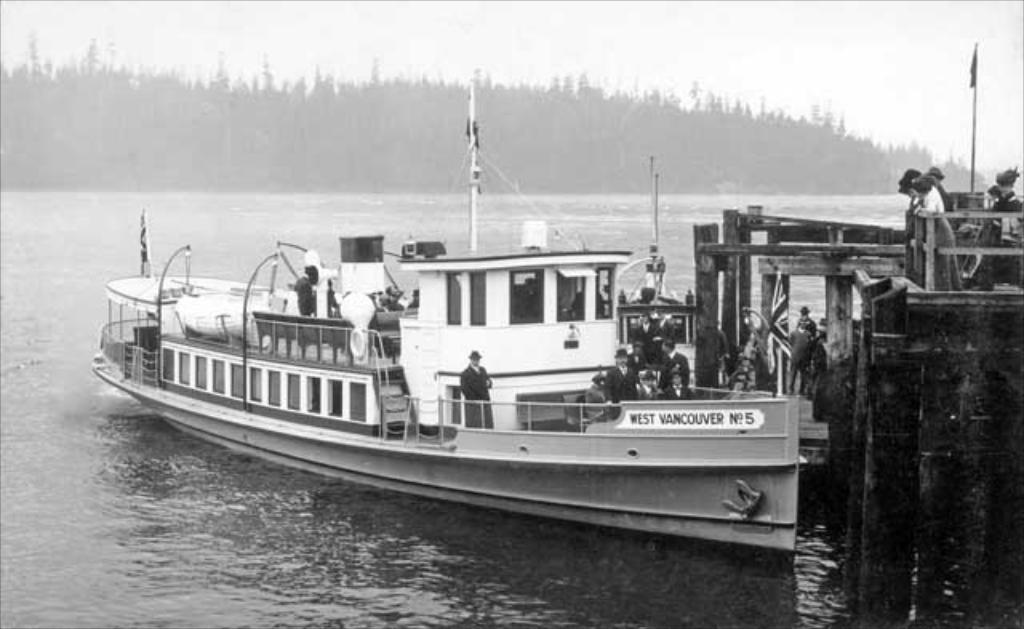<image>
Render a clear and concise summary of the photo. A boat called the West Vancouver No. 5 is pictured next to a pier. 